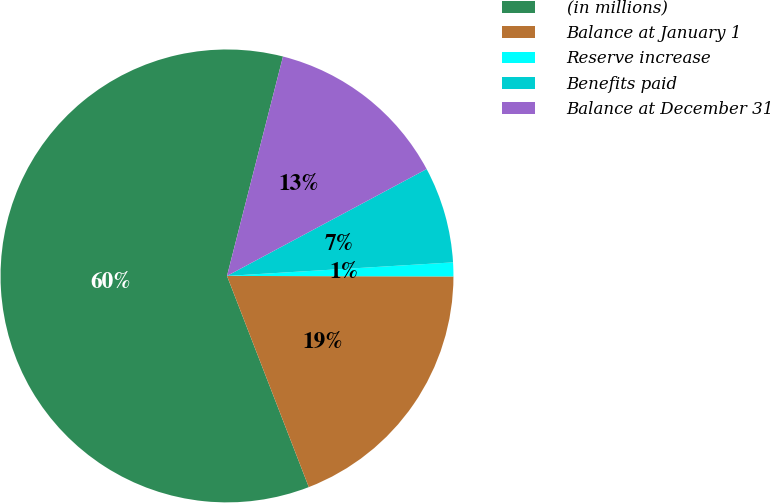Convert chart. <chart><loc_0><loc_0><loc_500><loc_500><pie_chart><fcel>(in millions)<fcel>Balance at January 1<fcel>Reserve increase<fcel>Benefits paid<fcel>Balance at December 31<nl><fcel>59.86%<fcel>19.08%<fcel>0.99%<fcel>6.87%<fcel>13.2%<nl></chart> 